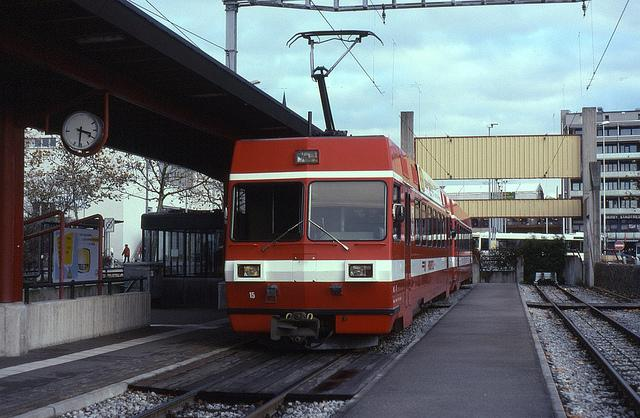How many hours until midnight? eight 